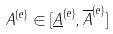Convert formula to latex. <formula><loc_0><loc_0><loc_500><loc_500>A ^ { ( e ) } \in [ \underline { A } ^ { ( e ) } , \overline { A } ^ { ( e ) } ]</formula> 